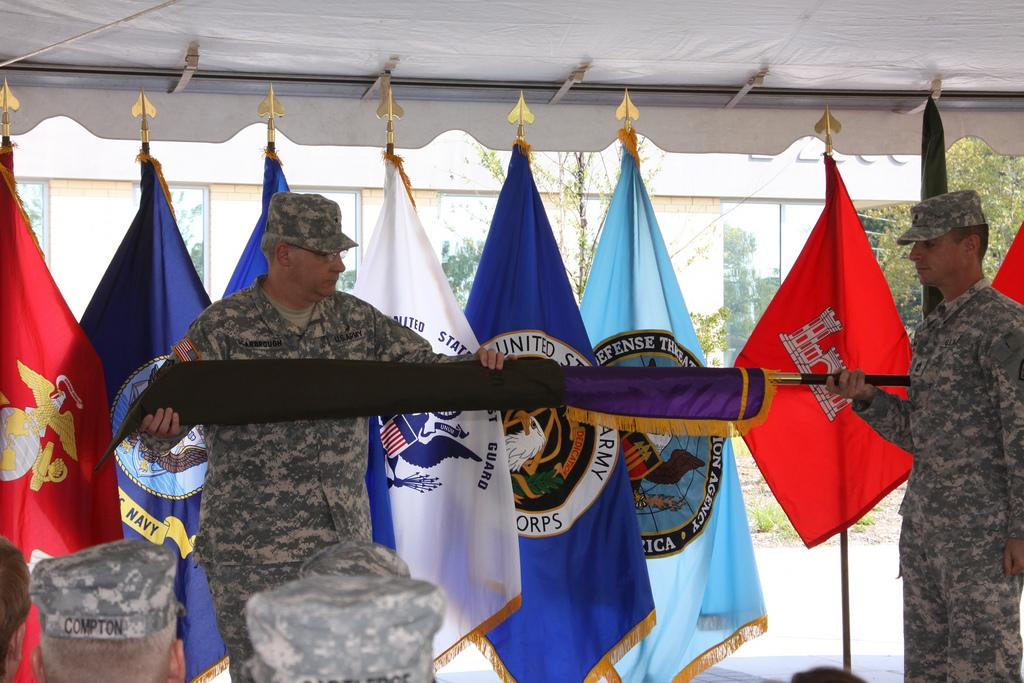How many army personnel are in the image? There are two army personnel holding a flag in the image. What are the two army personnel doing in the image? The two army personnel are holding a flag. Are there any other flags visible in the image? Yes, there are additional flags visible in the image. What is the position of the other army personnel in relation to the two holding the flag? There are other army personnel in front of the two holding the flag. How many babies are present in the image? There are no babies present in the image. What type of school is depicted in the image? There is no school depicted in the image. 